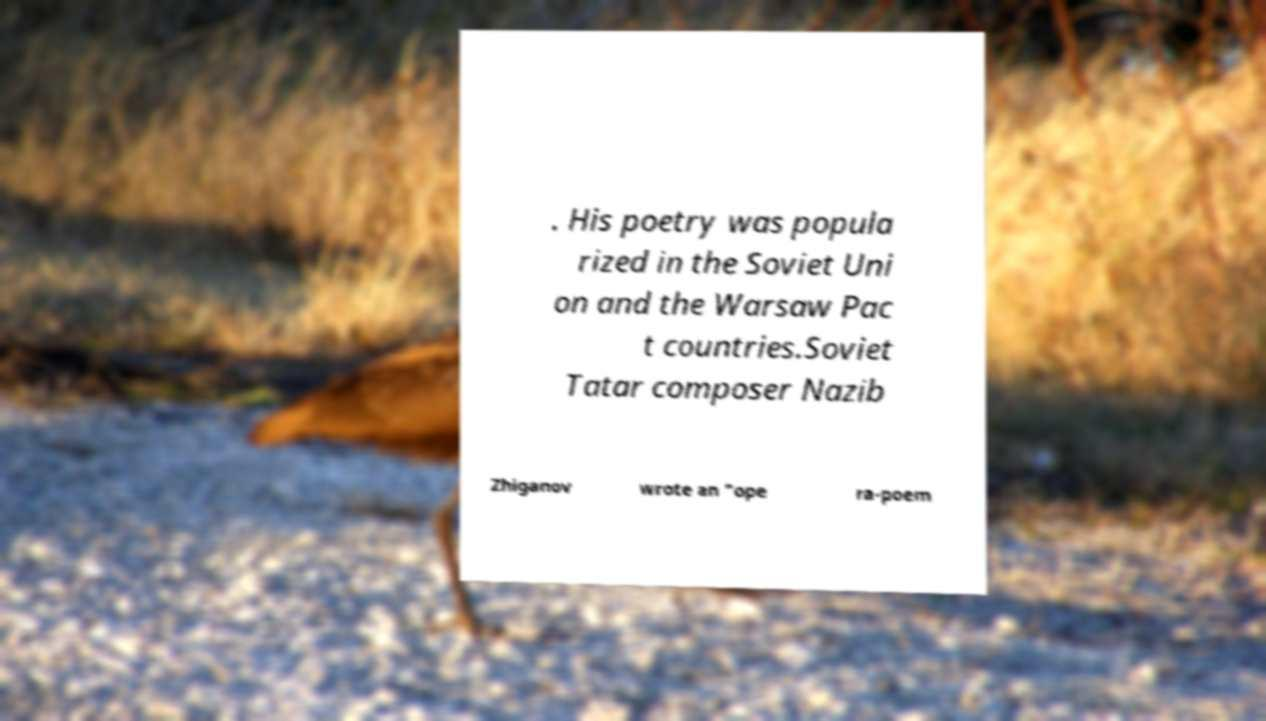Can you read and provide the text displayed in the image?This photo seems to have some interesting text. Can you extract and type it out for me? . His poetry was popula rized in the Soviet Uni on and the Warsaw Pac t countries.Soviet Tatar composer Nazib Zhiganov wrote an "ope ra-poem 